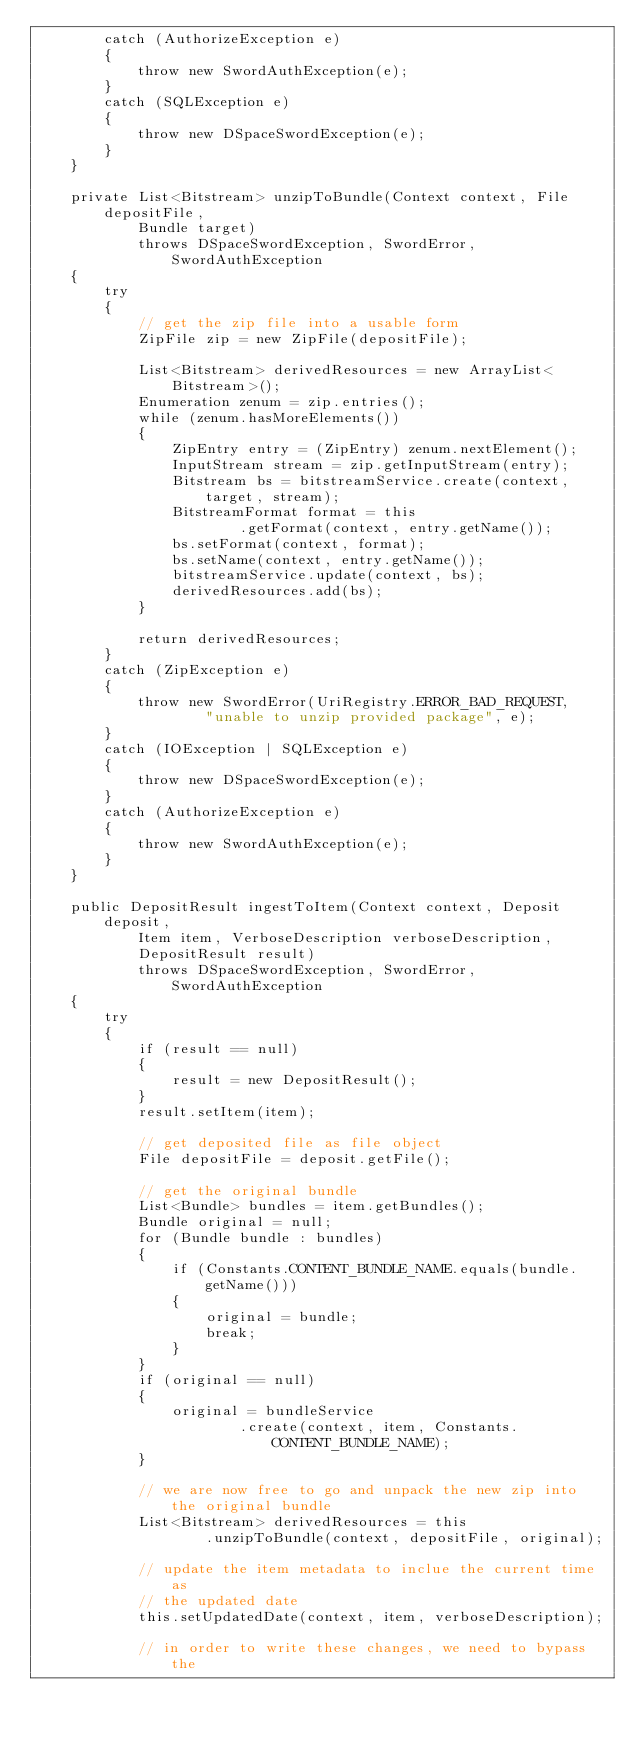<code> <loc_0><loc_0><loc_500><loc_500><_Java_>        catch (AuthorizeException e)
        {
            throw new SwordAuthException(e);
        }
        catch (SQLException e)
        {
            throw new DSpaceSwordException(e);
        }
    }

    private List<Bitstream> unzipToBundle(Context context, File depositFile,
            Bundle target)
            throws DSpaceSwordException, SwordError, SwordAuthException
    {
        try
        {
            // get the zip file into a usable form
            ZipFile zip = new ZipFile(depositFile);

            List<Bitstream> derivedResources = new ArrayList<Bitstream>();
            Enumeration zenum = zip.entries();
            while (zenum.hasMoreElements())
            {
                ZipEntry entry = (ZipEntry) zenum.nextElement();
                InputStream stream = zip.getInputStream(entry);
                Bitstream bs = bitstreamService.create(context, target, stream);
                BitstreamFormat format = this
                        .getFormat(context, entry.getName());
                bs.setFormat(context, format);
                bs.setName(context, entry.getName());
                bitstreamService.update(context, bs);
                derivedResources.add(bs);
            }

            return derivedResources;
        }
        catch (ZipException e)
        {
            throw new SwordError(UriRegistry.ERROR_BAD_REQUEST,
                    "unable to unzip provided package", e);
        }
        catch (IOException | SQLException e)
        {
            throw new DSpaceSwordException(e);
        }
        catch (AuthorizeException e)
        {
            throw new SwordAuthException(e);
        }
    }

    public DepositResult ingestToItem(Context context, Deposit deposit,
            Item item, VerboseDescription verboseDescription,
            DepositResult result)
            throws DSpaceSwordException, SwordError, SwordAuthException
    {
        try
        {
            if (result == null)
            {
                result = new DepositResult();
            }
            result.setItem(item);

            // get deposited file as file object
            File depositFile = deposit.getFile();

            // get the original bundle
            List<Bundle> bundles = item.getBundles();
            Bundle original = null;
            for (Bundle bundle : bundles)
            {
                if (Constants.CONTENT_BUNDLE_NAME.equals(bundle.getName()))
                {
                    original = bundle;
                    break;
                }
            }
            if (original == null)
            {
                original = bundleService
                        .create(context, item, Constants.CONTENT_BUNDLE_NAME);
            }

            // we are now free to go and unpack the new zip into the original bundle
            List<Bitstream> derivedResources = this
                    .unzipToBundle(context, depositFile, original);

            // update the item metadata to inclue the current time as
            // the updated date
            this.setUpdatedDate(context, item, verboseDescription);

            // in order to write these changes, we need to bypass the</code> 